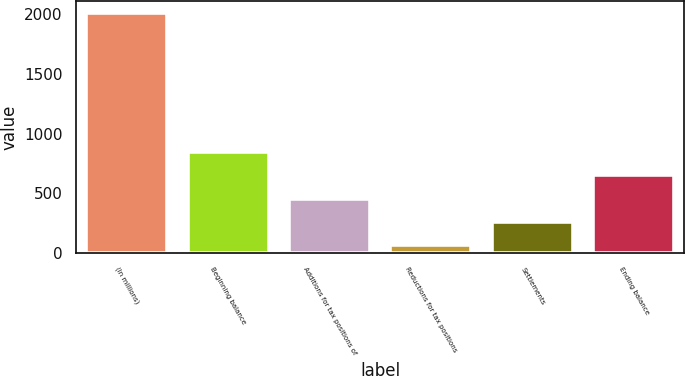Convert chart. <chart><loc_0><loc_0><loc_500><loc_500><bar_chart><fcel>(In millions)<fcel>Beginning balance<fcel>Additions for tax positions of<fcel>Reductions for tax positions<fcel>Settlements<fcel>Ending balance<nl><fcel>2012<fcel>845<fcel>456<fcel>67<fcel>261.5<fcel>650.5<nl></chart> 